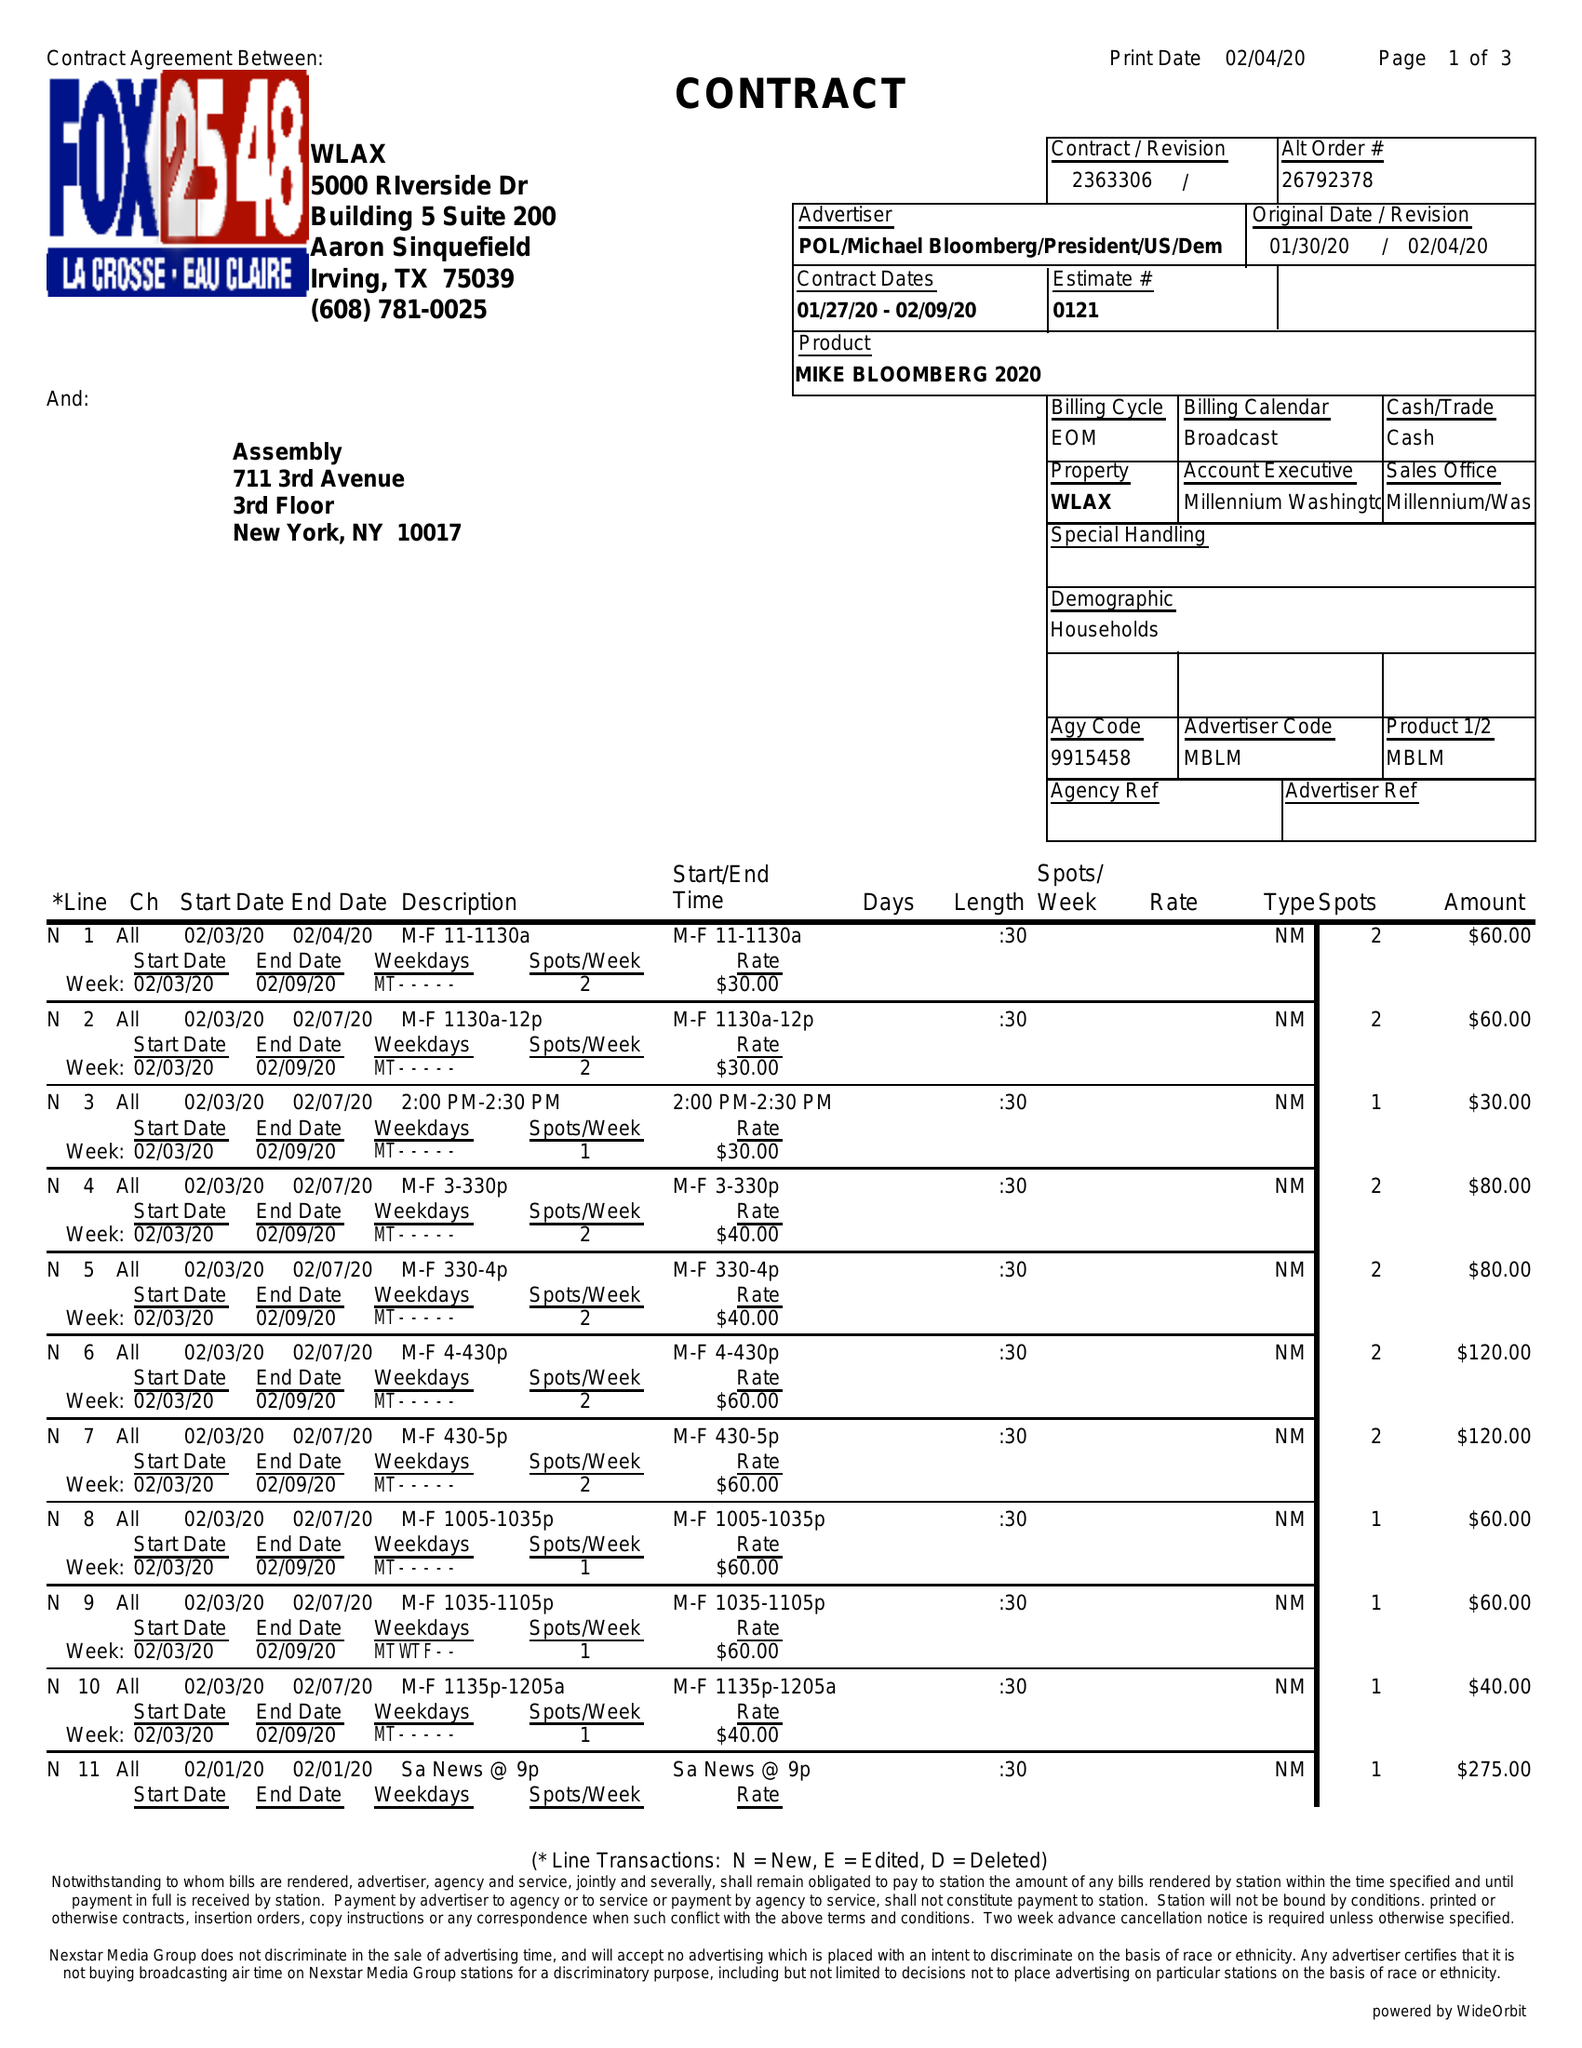What is the value for the contract_num?
Answer the question using a single word or phrase. 2363306 